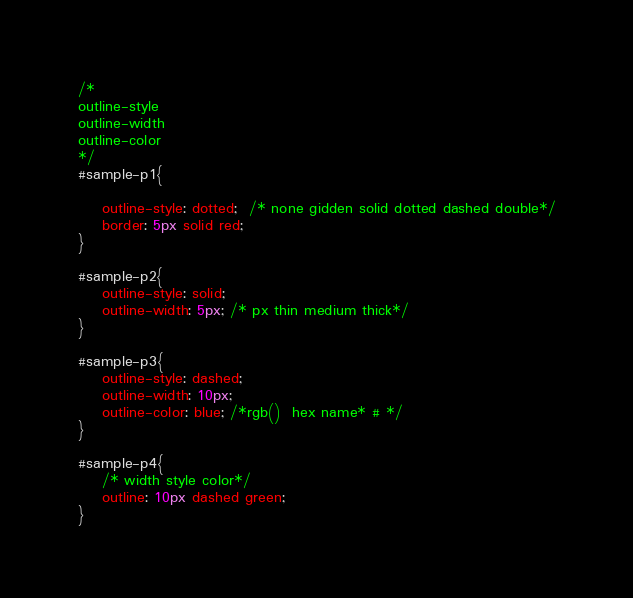<code> <loc_0><loc_0><loc_500><loc_500><_CSS_>/*
outline-style
outline-width
outline-color
*/
#sample-p1{
    
    outline-style: dotted;  /* none gidden solid dotted dashed double*/
    border: 5px solid red;
}

#sample-p2{
    outline-style: solid;
    outline-width: 5px; /* px thin medium thick*/
}

#sample-p3{
    outline-style: dashed;
    outline-width: 10px;
    outline-color: blue; /*rgb()  hex name* # */
}

#sample-p4{
    /* width style color*/
    outline: 10px dashed green;
}</code> 